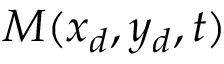Convert formula to latex. <formula><loc_0><loc_0><loc_500><loc_500>M ( x _ { d } , y _ { d } , t )</formula> 